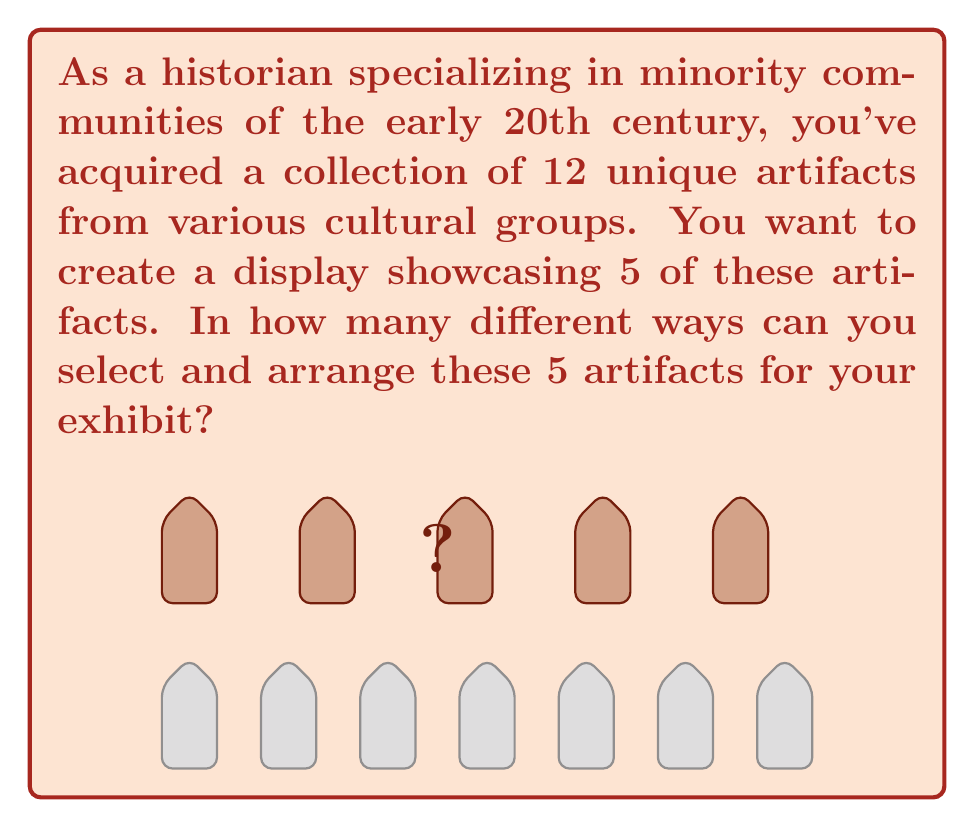Can you answer this question? To solve this problem, we need to consider both the selection of artifacts and their arrangement. This is a perfect scenario for using the concept of permutations.

Step 1: Determine the type of permutation
We are selecting 5 artifacts from 12 and the order matters (arrangement), so we use permutations without repetition.

Step 2: Apply the permutation formula
The formula for permutations without repetition is:

$$P(n,r) = \frac{n!}{(n-r)!}$$

Where $n$ is the total number of items to choose from, and $r$ is the number of items being chosen.

In this case, $n = 12$ (total artifacts) and $r = 5$ (artifacts in the display).

Step 3: Calculate the permutation
$$P(12,5) = \frac{12!}{(12-5)!} = \frac{12!}{7!}$$

Step 4: Simplify the calculation
$$\frac{12!}{7!} = 12 \times 11 \times 10 \times 9 \times 8 = 95,040$$

Therefore, there are 95,040 different ways to select and arrange 5 artifacts from the collection of 12 for the exhibit.
Answer: $95,040$ 